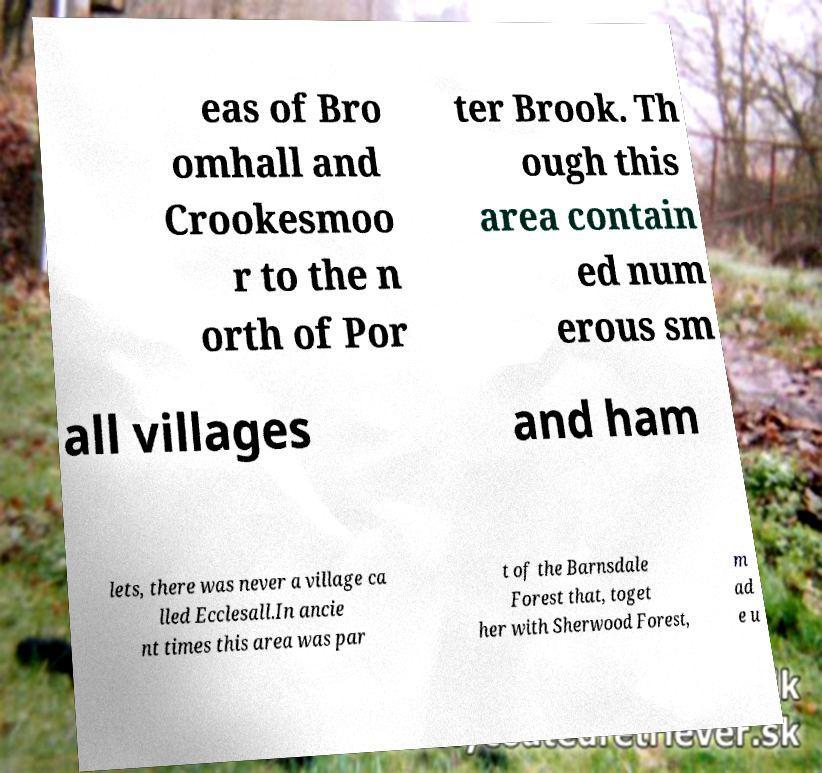There's text embedded in this image that I need extracted. Can you transcribe it verbatim? eas of Bro omhall and Crookesmoo r to the n orth of Por ter Brook. Th ough this area contain ed num erous sm all villages and ham lets, there was never a village ca lled Ecclesall.In ancie nt times this area was par t of the Barnsdale Forest that, toget her with Sherwood Forest, m ad e u 